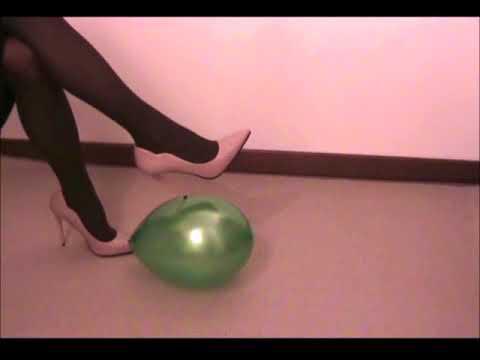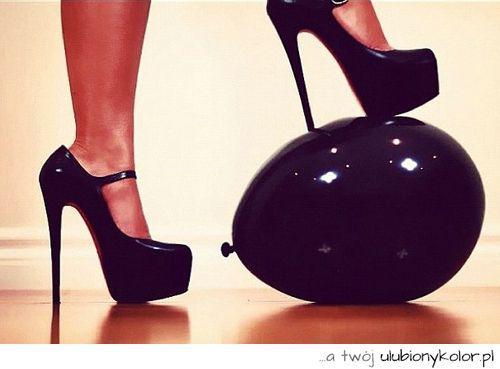The first image is the image on the left, the second image is the image on the right. For the images displayed, is the sentence "There are two women stepping on balloons." factually correct? Answer yes or no. Yes. 